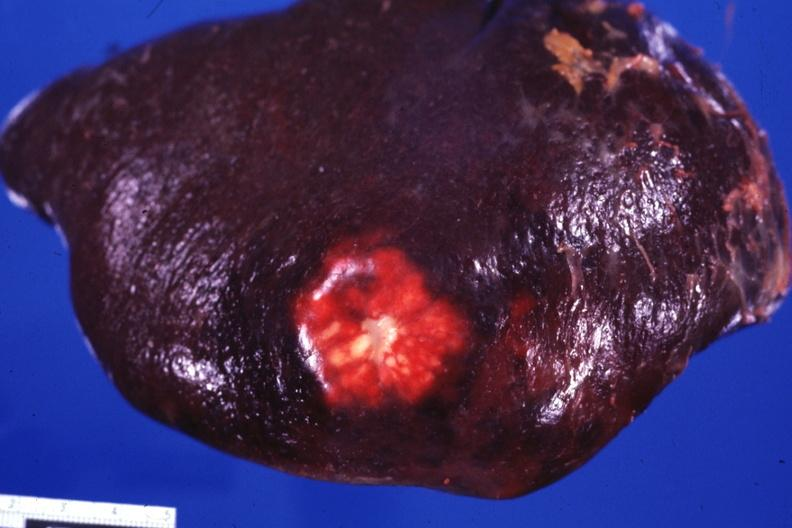what is present?
Answer the question using a single word or phrase. Spleen 